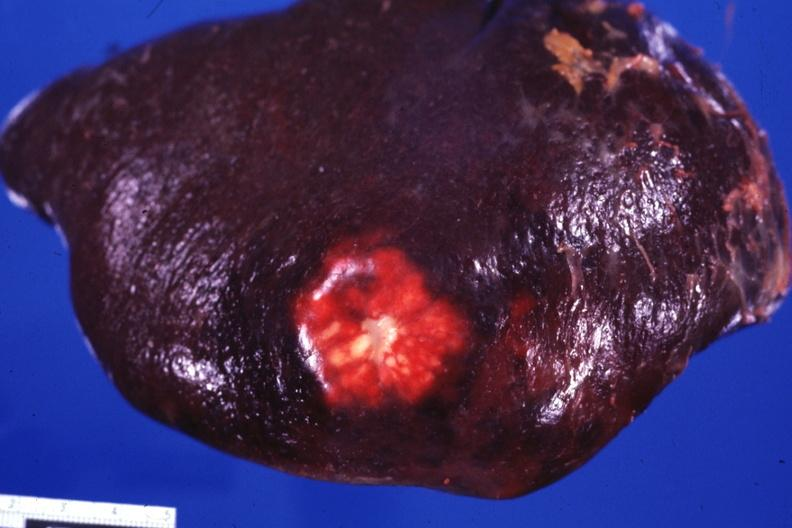what is present?
Answer the question using a single word or phrase. Spleen 